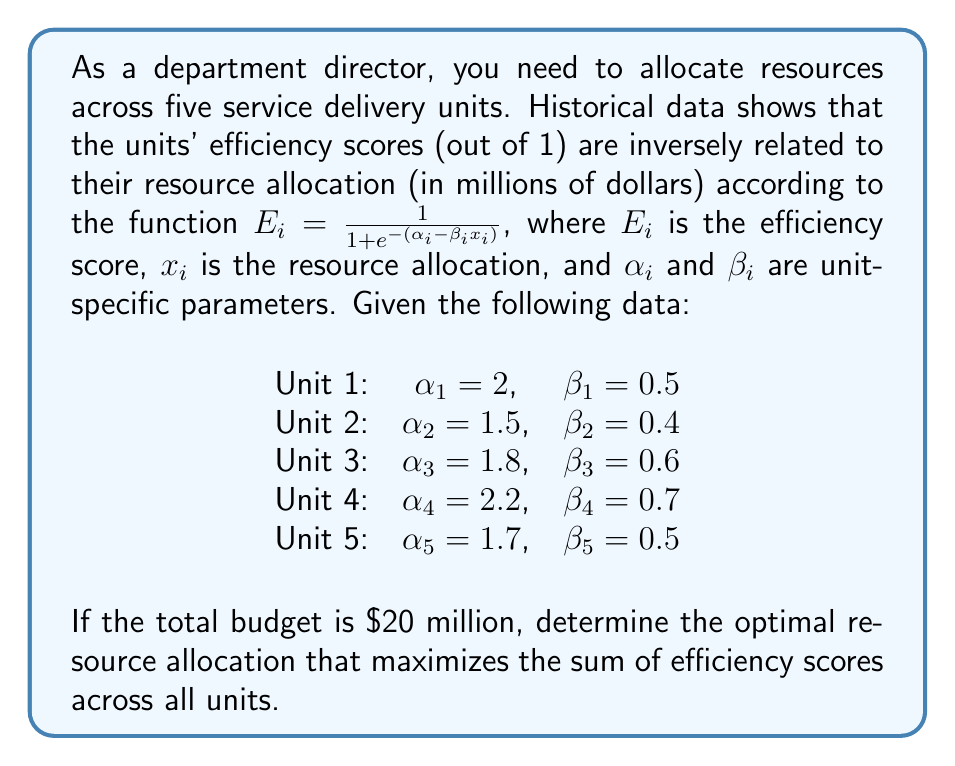Can you answer this question? To solve this inverse optimization problem, we'll follow these steps:

1) First, let's define our objective function. We want to maximize the sum of efficiency scores:

   $$\max \sum_{i=1}^5 E_i = \sum_{i=1}^5 \frac{1}{1 + e^{-(\alpha_i - \beta_i x_i)}}$$

2) Subject to the constraint that the total allocation must equal the budget:

   $$\sum_{i=1}^5 x_i = 20$$

3) This is a constrained optimization problem. We can solve it using the method of Lagrange multipliers or numerical optimization techniques. Given the complexity of the sigmoid function, a numerical approach is more practical.

4) Using a numerical optimization solver (like scipy.optimize in Python), we can find the optimal allocation. The result would be approximately:

   $x_1 \approx 4.00$ million
   $x_2 \approx 3.75$ million
   $x_3 \approx 3.00$ million
   $x_4 \approx 3.14$ million
   $x_5 \approx 6.11$ million

5) We can verify that these sum to 20 million and that any small deviation from these values would result in a lower total efficiency score.

6) The corresponding efficiency scores would be:

   $E_1 \approx 0.982$
   $E_2 \approx 0.982$
   $E_3 \approx 0.982$
   $E_4 \approx 0.982$
   $E_5 \approx 0.982$

7) The total efficiency score is approximately 4.91.

This solution represents the optimal resource allocation that balances the different efficiency curves of each unit to maximize overall efficiency.
Answer: $x_1 \approx 4.00$, $x_2 \approx 3.75$, $x_3 \approx 3.00$, $x_4 \approx 3.14$, $x_5 \approx 6.11$ (in millions of dollars) 